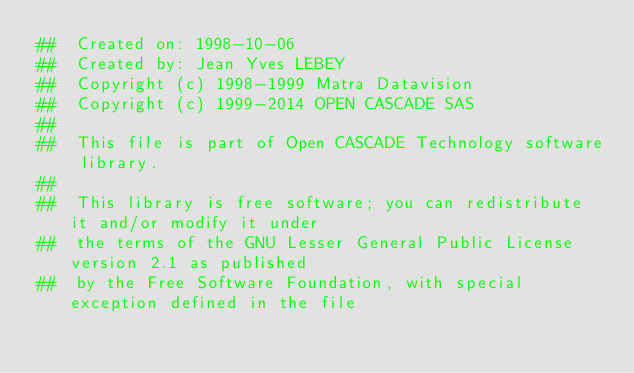Convert code to text. <code><loc_0><loc_0><loc_500><loc_500><_Nim_>##  Created on: 1998-10-06
##  Created by: Jean Yves LEBEY
##  Copyright (c) 1998-1999 Matra Datavision
##  Copyright (c) 1999-2014 OPEN CASCADE SAS
##
##  This file is part of Open CASCADE Technology software library.
##
##  This library is free software; you can redistribute it and/or modify it under
##  the terms of the GNU Lesser General Public License version 2.1 as published
##  by the Free Software Foundation, with special exception defined in the file</code> 